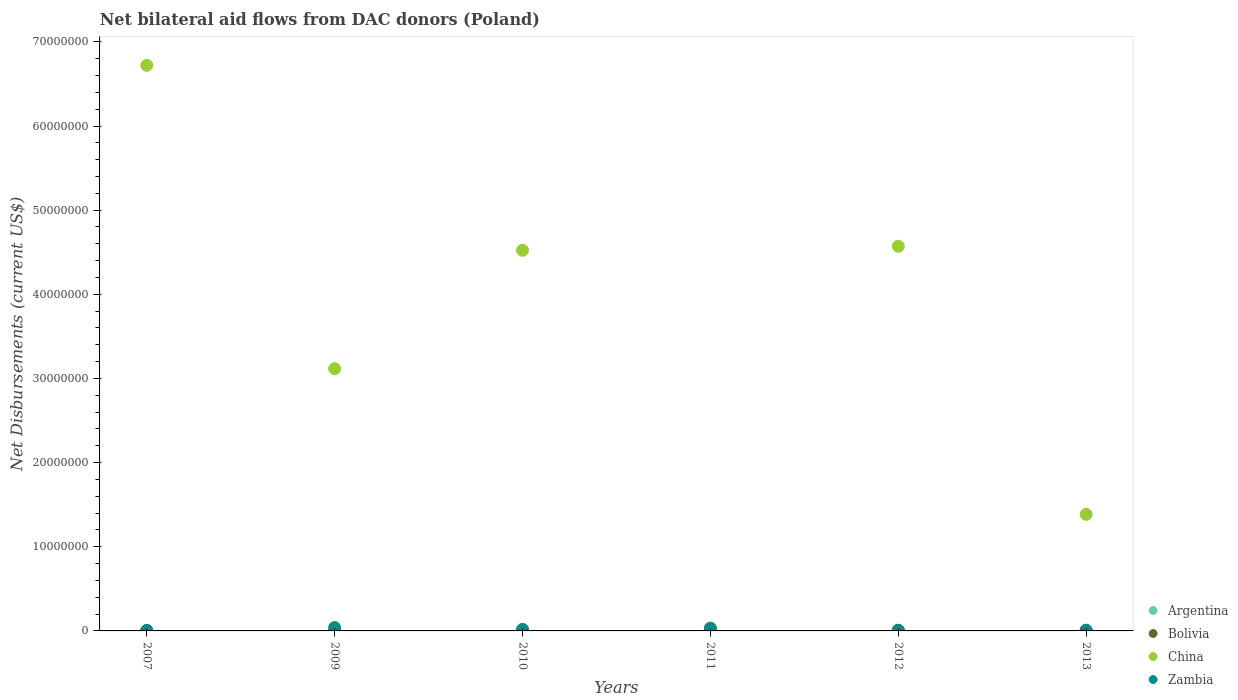How many different coloured dotlines are there?
Your answer should be very brief. 4. Is the number of dotlines equal to the number of legend labels?
Provide a succinct answer. No. What is the net bilateral aid flows in China in 2010?
Provide a short and direct response. 4.52e+07. Across all years, what is the maximum net bilateral aid flows in China?
Provide a succinct answer. 6.72e+07. What is the total net bilateral aid flows in Argentina in the graph?
Ensure brevity in your answer.  1.30e+05. What is the difference between the net bilateral aid flows in China in 2009 and that in 2012?
Make the answer very short. -1.46e+07. What is the difference between the net bilateral aid flows in Argentina in 2013 and the net bilateral aid flows in China in 2007?
Your response must be concise. -6.72e+07. What is the average net bilateral aid flows in China per year?
Offer a very short reply. 3.39e+07. In the year 2007, what is the difference between the net bilateral aid flows in China and net bilateral aid flows in Bolivia?
Offer a terse response. 6.72e+07. In how many years, is the net bilateral aid flows in Bolivia greater than 12000000 US$?
Make the answer very short. 0. What is the ratio of the net bilateral aid flows in Bolivia in 2007 to that in 2011?
Ensure brevity in your answer.  0.12. Is the difference between the net bilateral aid flows in China in 2009 and 2010 greater than the difference between the net bilateral aid flows in Bolivia in 2009 and 2010?
Provide a short and direct response. No. What is the difference between the highest and the second highest net bilateral aid flows in China?
Provide a short and direct response. 2.15e+07. What is the difference between the highest and the lowest net bilateral aid flows in China?
Provide a short and direct response. 6.72e+07. In how many years, is the net bilateral aid flows in Bolivia greater than the average net bilateral aid flows in Bolivia taken over all years?
Your answer should be very brief. 3. Is it the case that in every year, the sum of the net bilateral aid flows in Zambia and net bilateral aid flows in Bolivia  is greater than the sum of net bilateral aid flows in Argentina and net bilateral aid flows in China?
Offer a very short reply. No. How many dotlines are there?
Offer a terse response. 4. How many years are there in the graph?
Offer a very short reply. 6. Are the values on the major ticks of Y-axis written in scientific E-notation?
Offer a very short reply. No. Does the graph contain any zero values?
Give a very brief answer. Yes. Where does the legend appear in the graph?
Provide a succinct answer. Bottom right. How many legend labels are there?
Your response must be concise. 4. What is the title of the graph?
Make the answer very short. Net bilateral aid flows from DAC donors (Poland). Does "Madagascar" appear as one of the legend labels in the graph?
Make the answer very short. No. What is the label or title of the X-axis?
Your answer should be compact. Years. What is the label or title of the Y-axis?
Offer a very short reply. Net Disbursements (current US$). What is the Net Disbursements (current US$) of Bolivia in 2007?
Your answer should be very brief. 10000. What is the Net Disbursements (current US$) in China in 2007?
Your answer should be compact. 6.72e+07. What is the Net Disbursements (current US$) in China in 2009?
Give a very brief answer. 3.12e+07. What is the Net Disbursements (current US$) in Bolivia in 2010?
Your response must be concise. 3.00e+04. What is the Net Disbursements (current US$) of China in 2010?
Offer a terse response. 4.52e+07. What is the Net Disbursements (current US$) of Argentina in 2011?
Provide a short and direct response. 10000. What is the Net Disbursements (current US$) of Bolivia in 2011?
Give a very brief answer. 8.00e+04. What is the Net Disbursements (current US$) of China in 2011?
Give a very brief answer. 0. What is the Net Disbursements (current US$) of Zambia in 2011?
Provide a short and direct response. 3.30e+05. What is the Net Disbursements (current US$) in Bolivia in 2012?
Make the answer very short. 8.00e+04. What is the Net Disbursements (current US$) of China in 2012?
Ensure brevity in your answer.  4.57e+07. What is the Net Disbursements (current US$) in Zambia in 2012?
Your response must be concise. 6.00e+04. What is the Net Disbursements (current US$) in Argentina in 2013?
Offer a very short reply. 2.00e+04. What is the Net Disbursements (current US$) in China in 2013?
Give a very brief answer. 1.38e+07. Across all years, what is the maximum Net Disbursements (current US$) in Argentina?
Give a very brief answer. 5.00e+04. Across all years, what is the maximum Net Disbursements (current US$) of Bolivia?
Offer a very short reply. 9.00e+04. Across all years, what is the maximum Net Disbursements (current US$) of China?
Your answer should be compact. 6.72e+07. Across all years, what is the maximum Net Disbursements (current US$) of Zambia?
Provide a short and direct response. 4.00e+05. Across all years, what is the minimum Net Disbursements (current US$) in Argentina?
Provide a succinct answer. 10000. Across all years, what is the minimum Net Disbursements (current US$) in Bolivia?
Offer a terse response. 10000. Across all years, what is the minimum Net Disbursements (current US$) of China?
Offer a very short reply. 0. Across all years, what is the minimum Net Disbursements (current US$) of Zambia?
Keep it short and to the point. 6.00e+04. What is the total Net Disbursements (current US$) of Argentina in the graph?
Offer a terse response. 1.30e+05. What is the total Net Disbursements (current US$) of China in the graph?
Keep it short and to the point. 2.03e+08. What is the total Net Disbursements (current US$) in Zambia in the graph?
Keep it short and to the point. 1.10e+06. What is the difference between the Net Disbursements (current US$) in China in 2007 and that in 2009?
Make the answer very short. 3.60e+07. What is the difference between the Net Disbursements (current US$) in Zambia in 2007 and that in 2009?
Provide a short and direct response. -3.40e+05. What is the difference between the Net Disbursements (current US$) in Argentina in 2007 and that in 2010?
Your response must be concise. 4.00e+04. What is the difference between the Net Disbursements (current US$) of China in 2007 and that in 2010?
Your answer should be compact. 2.20e+07. What is the difference between the Net Disbursements (current US$) of Zambia in 2007 and that in 2010?
Your response must be concise. -1.30e+05. What is the difference between the Net Disbursements (current US$) in Bolivia in 2007 and that in 2011?
Your answer should be compact. -7.00e+04. What is the difference between the Net Disbursements (current US$) in Argentina in 2007 and that in 2012?
Your answer should be very brief. 3.00e+04. What is the difference between the Net Disbursements (current US$) of China in 2007 and that in 2012?
Give a very brief answer. 2.15e+07. What is the difference between the Net Disbursements (current US$) in Zambia in 2007 and that in 2012?
Provide a short and direct response. 0. What is the difference between the Net Disbursements (current US$) in Argentina in 2007 and that in 2013?
Ensure brevity in your answer.  3.00e+04. What is the difference between the Net Disbursements (current US$) of Bolivia in 2007 and that in 2013?
Offer a terse response. -8.00e+04. What is the difference between the Net Disbursements (current US$) in China in 2007 and that in 2013?
Your response must be concise. 5.34e+07. What is the difference between the Net Disbursements (current US$) in Argentina in 2009 and that in 2010?
Keep it short and to the point. 10000. What is the difference between the Net Disbursements (current US$) in China in 2009 and that in 2010?
Provide a short and direct response. -1.41e+07. What is the difference between the Net Disbursements (current US$) of Zambia in 2009 and that in 2010?
Offer a very short reply. 2.10e+05. What is the difference between the Net Disbursements (current US$) in Argentina in 2009 and that in 2011?
Your answer should be very brief. 10000. What is the difference between the Net Disbursements (current US$) of Bolivia in 2009 and that in 2012?
Offer a very short reply. -4.00e+04. What is the difference between the Net Disbursements (current US$) of China in 2009 and that in 2012?
Give a very brief answer. -1.46e+07. What is the difference between the Net Disbursements (current US$) in Zambia in 2009 and that in 2012?
Give a very brief answer. 3.40e+05. What is the difference between the Net Disbursements (current US$) in Argentina in 2009 and that in 2013?
Your answer should be very brief. 0. What is the difference between the Net Disbursements (current US$) of China in 2009 and that in 2013?
Your response must be concise. 1.73e+07. What is the difference between the Net Disbursements (current US$) of Argentina in 2010 and that in 2011?
Provide a short and direct response. 0. What is the difference between the Net Disbursements (current US$) in Zambia in 2010 and that in 2011?
Offer a terse response. -1.40e+05. What is the difference between the Net Disbursements (current US$) of Argentina in 2010 and that in 2012?
Offer a terse response. -10000. What is the difference between the Net Disbursements (current US$) in Bolivia in 2010 and that in 2012?
Ensure brevity in your answer.  -5.00e+04. What is the difference between the Net Disbursements (current US$) in China in 2010 and that in 2012?
Ensure brevity in your answer.  -4.80e+05. What is the difference between the Net Disbursements (current US$) in Zambia in 2010 and that in 2012?
Provide a short and direct response. 1.30e+05. What is the difference between the Net Disbursements (current US$) in Argentina in 2010 and that in 2013?
Make the answer very short. -10000. What is the difference between the Net Disbursements (current US$) in China in 2010 and that in 2013?
Make the answer very short. 3.14e+07. What is the difference between the Net Disbursements (current US$) in Zambia in 2010 and that in 2013?
Your response must be concise. 1.30e+05. What is the difference between the Net Disbursements (current US$) of Bolivia in 2011 and that in 2012?
Ensure brevity in your answer.  0. What is the difference between the Net Disbursements (current US$) in Zambia in 2011 and that in 2012?
Give a very brief answer. 2.70e+05. What is the difference between the Net Disbursements (current US$) in Argentina in 2011 and that in 2013?
Keep it short and to the point. -10000. What is the difference between the Net Disbursements (current US$) in Bolivia in 2011 and that in 2013?
Provide a succinct answer. -10000. What is the difference between the Net Disbursements (current US$) in Argentina in 2012 and that in 2013?
Your response must be concise. 0. What is the difference between the Net Disbursements (current US$) in China in 2012 and that in 2013?
Keep it short and to the point. 3.19e+07. What is the difference between the Net Disbursements (current US$) in Zambia in 2012 and that in 2013?
Give a very brief answer. 0. What is the difference between the Net Disbursements (current US$) of Argentina in 2007 and the Net Disbursements (current US$) of China in 2009?
Keep it short and to the point. -3.11e+07. What is the difference between the Net Disbursements (current US$) in Argentina in 2007 and the Net Disbursements (current US$) in Zambia in 2009?
Offer a terse response. -3.50e+05. What is the difference between the Net Disbursements (current US$) of Bolivia in 2007 and the Net Disbursements (current US$) of China in 2009?
Ensure brevity in your answer.  -3.12e+07. What is the difference between the Net Disbursements (current US$) in Bolivia in 2007 and the Net Disbursements (current US$) in Zambia in 2009?
Your answer should be compact. -3.90e+05. What is the difference between the Net Disbursements (current US$) in China in 2007 and the Net Disbursements (current US$) in Zambia in 2009?
Ensure brevity in your answer.  6.68e+07. What is the difference between the Net Disbursements (current US$) in Argentina in 2007 and the Net Disbursements (current US$) in China in 2010?
Provide a short and direct response. -4.52e+07. What is the difference between the Net Disbursements (current US$) in Bolivia in 2007 and the Net Disbursements (current US$) in China in 2010?
Provide a succinct answer. -4.52e+07. What is the difference between the Net Disbursements (current US$) in Bolivia in 2007 and the Net Disbursements (current US$) in Zambia in 2010?
Give a very brief answer. -1.80e+05. What is the difference between the Net Disbursements (current US$) in China in 2007 and the Net Disbursements (current US$) in Zambia in 2010?
Make the answer very short. 6.70e+07. What is the difference between the Net Disbursements (current US$) of Argentina in 2007 and the Net Disbursements (current US$) of Bolivia in 2011?
Your response must be concise. -3.00e+04. What is the difference between the Net Disbursements (current US$) in Argentina in 2007 and the Net Disbursements (current US$) in Zambia in 2011?
Give a very brief answer. -2.80e+05. What is the difference between the Net Disbursements (current US$) in Bolivia in 2007 and the Net Disbursements (current US$) in Zambia in 2011?
Ensure brevity in your answer.  -3.20e+05. What is the difference between the Net Disbursements (current US$) in China in 2007 and the Net Disbursements (current US$) in Zambia in 2011?
Your response must be concise. 6.69e+07. What is the difference between the Net Disbursements (current US$) in Argentina in 2007 and the Net Disbursements (current US$) in China in 2012?
Make the answer very short. -4.57e+07. What is the difference between the Net Disbursements (current US$) of Bolivia in 2007 and the Net Disbursements (current US$) of China in 2012?
Offer a terse response. -4.57e+07. What is the difference between the Net Disbursements (current US$) in China in 2007 and the Net Disbursements (current US$) in Zambia in 2012?
Provide a short and direct response. 6.72e+07. What is the difference between the Net Disbursements (current US$) in Argentina in 2007 and the Net Disbursements (current US$) in China in 2013?
Your answer should be compact. -1.38e+07. What is the difference between the Net Disbursements (current US$) of Argentina in 2007 and the Net Disbursements (current US$) of Zambia in 2013?
Ensure brevity in your answer.  -10000. What is the difference between the Net Disbursements (current US$) of Bolivia in 2007 and the Net Disbursements (current US$) of China in 2013?
Your answer should be compact. -1.38e+07. What is the difference between the Net Disbursements (current US$) in China in 2007 and the Net Disbursements (current US$) in Zambia in 2013?
Ensure brevity in your answer.  6.72e+07. What is the difference between the Net Disbursements (current US$) of Argentina in 2009 and the Net Disbursements (current US$) of Bolivia in 2010?
Make the answer very short. -10000. What is the difference between the Net Disbursements (current US$) of Argentina in 2009 and the Net Disbursements (current US$) of China in 2010?
Make the answer very short. -4.52e+07. What is the difference between the Net Disbursements (current US$) of Bolivia in 2009 and the Net Disbursements (current US$) of China in 2010?
Your response must be concise. -4.52e+07. What is the difference between the Net Disbursements (current US$) of Bolivia in 2009 and the Net Disbursements (current US$) of Zambia in 2010?
Offer a very short reply. -1.50e+05. What is the difference between the Net Disbursements (current US$) of China in 2009 and the Net Disbursements (current US$) of Zambia in 2010?
Provide a succinct answer. 3.10e+07. What is the difference between the Net Disbursements (current US$) of Argentina in 2009 and the Net Disbursements (current US$) of Zambia in 2011?
Make the answer very short. -3.10e+05. What is the difference between the Net Disbursements (current US$) in China in 2009 and the Net Disbursements (current US$) in Zambia in 2011?
Your answer should be compact. 3.08e+07. What is the difference between the Net Disbursements (current US$) in Argentina in 2009 and the Net Disbursements (current US$) in Bolivia in 2012?
Provide a succinct answer. -6.00e+04. What is the difference between the Net Disbursements (current US$) of Argentina in 2009 and the Net Disbursements (current US$) of China in 2012?
Ensure brevity in your answer.  -4.57e+07. What is the difference between the Net Disbursements (current US$) of Argentina in 2009 and the Net Disbursements (current US$) of Zambia in 2012?
Your answer should be compact. -4.00e+04. What is the difference between the Net Disbursements (current US$) of Bolivia in 2009 and the Net Disbursements (current US$) of China in 2012?
Provide a succinct answer. -4.57e+07. What is the difference between the Net Disbursements (current US$) of China in 2009 and the Net Disbursements (current US$) of Zambia in 2012?
Provide a succinct answer. 3.11e+07. What is the difference between the Net Disbursements (current US$) of Argentina in 2009 and the Net Disbursements (current US$) of Bolivia in 2013?
Keep it short and to the point. -7.00e+04. What is the difference between the Net Disbursements (current US$) in Argentina in 2009 and the Net Disbursements (current US$) in China in 2013?
Your answer should be very brief. -1.38e+07. What is the difference between the Net Disbursements (current US$) of Bolivia in 2009 and the Net Disbursements (current US$) of China in 2013?
Your response must be concise. -1.38e+07. What is the difference between the Net Disbursements (current US$) in Bolivia in 2009 and the Net Disbursements (current US$) in Zambia in 2013?
Provide a succinct answer. -2.00e+04. What is the difference between the Net Disbursements (current US$) in China in 2009 and the Net Disbursements (current US$) in Zambia in 2013?
Ensure brevity in your answer.  3.11e+07. What is the difference between the Net Disbursements (current US$) in Argentina in 2010 and the Net Disbursements (current US$) in Zambia in 2011?
Give a very brief answer. -3.20e+05. What is the difference between the Net Disbursements (current US$) of Bolivia in 2010 and the Net Disbursements (current US$) of Zambia in 2011?
Keep it short and to the point. -3.00e+05. What is the difference between the Net Disbursements (current US$) of China in 2010 and the Net Disbursements (current US$) of Zambia in 2011?
Offer a very short reply. 4.49e+07. What is the difference between the Net Disbursements (current US$) of Argentina in 2010 and the Net Disbursements (current US$) of China in 2012?
Ensure brevity in your answer.  -4.57e+07. What is the difference between the Net Disbursements (current US$) of Bolivia in 2010 and the Net Disbursements (current US$) of China in 2012?
Offer a terse response. -4.57e+07. What is the difference between the Net Disbursements (current US$) of Bolivia in 2010 and the Net Disbursements (current US$) of Zambia in 2012?
Provide a succinct answer. -3.00e+04. What is the difference between the Net Disbursements (current US$) of China in 2010 and the Net Disbursements (current US$) of Zambia in 2012?
Your answer should be very brief. 4.52e+07. What is the difference between the Net Disbursements (current US$) of Argentina in 2010 and the Net Disbursements (current US$) of China in 2013?
Offer a terse response. -1.38e+07. What is the difference between the Net Disbursements (current US$) of Bolivia in 2010 and the Net Disbursements (current US$) of China in 2013?
Your answer should be compact. -1.38e+07. What is the difference between the Net Disbursements (current US$) in China in 2010 and the Net Disbursements (current US$) in Zambia in 2013?
Your response must be concise. 4.52e+07. What is the difference between the Net Disbursements (current US$) in Argentina in 2011 and the Net Disbursements (current US$) in China in 2012?
Offer a terse response. -4.57e+07. What is the difference between the Net Disbursements (current US$) in Argentina in 2011 and the Net Disbursements (current US$) in Zambia in 2012?
Offer a very short reply. -5.00e+04. What is the difference between the Net Disbursements (current US$) in Bolivia in 2011 and the Net Disbursements (current US$) in China in 2012?
Your answer should be compact. -4.56e+07. What is the difference between the Net Disbursements (current US$) of Bolivia in 2011 and the Net Disbursements (current US$) of Zambia in 2012?
Provide a short and direct response. 2.00e+04. What is the difference between the Net Disbursements (current US$) in Argentina in 2011 and the Net Disbursements (current US$) in China in 2013?
Ensure brevity in your answer.  -1.38e+07. What is the difference between the Net Disbursements (current US$) of Argentina in 2011 and the Net Disbursements (current US$) of Zambia in 2013?
Keep it short and to the point. -5.00e+04. What is the difference between the Net Disbursements (current US$) of Bolivia in 2011 and the Net Disbursements (current US$) of China in 2013?
Keep it short and to the point. -1.38e+07. What is the difference between the Net Disbursements (current US$) in Bolivia in 2011 and the Net Disbursements (current US$) in Zambia in 2013?
Make the answer very short. 2.00e+04. What is the difference between the Net Disbursements (current US$) in Argentina in 2012 and the Net Disbursements (current US$) in Bolivia in 2013?
Offer a terse response. -7.00e+04. What is the difference between the Net Disbursements (current US$) in Argentina in 2012 and the Net Disbursements (current US$) in China in 2013?
Offer a terse response. -1.38e+07. What is the difference between the Net Disbursements (current US$) in Bolivia in 2012 and the Net Disbursements (current US$) in China in 2013?
Your response must be concise. -1.38e+07. What is the difference between the Net Disbursements (current US$) of Bolivia in 2012 and the Net Disbursements (current US$) of Zambia in 2013?
Your answer should be compact. 2.00e+04. What is the difference between the Net Disbursements (current US$) of China in 2012 and the Net Disbursements (current US$) of Zambia in 2013?
Offer a very short reply. 4.56e+07. What is the average Net Disbursements (current US$) in Argentina per year?
Keep it short and to the point. 2.17e+04. What is the average Net Disbursements (current US$) in Bolivia per year?
Keep it short and to the point. 5.50e+04. What is the average Net Disbursements (current US$) in China per year?
Offer a very short reply. 3.39e+07. What is the average Net Disbursements (current US$) of Zambia per year?
Ensure brevity in your answer.  1.83e+05. In the year 2007, what is the difference between the Net Disbursements (current US$) in Argentina and Net Disbursements (current US$) in China?
Keep it short and to the point. -6.72e+07. In the year 2007, what is the difference between the Net Disbursements (current US$) in Argentina and Net Disbursements (current US$) in Zambia?
Provide a succinct answer. -10000. In the year 2007, what is the difference between the Net Disbursements (current US$) in Bolivia and Net Disbursements (current US$) in China?
Give a very brief answer. -6.72e+07. In the year 2007, what is the difference between the Net Disbursements (current US$) of China and Net Disbursements (current US$) of Zambia?
Your answer should be very brief. 6.72e+07. In the year 2009, what is the difference between the Net Disbursements (current US$) of Argentina and Net Disbursements (current US$) of China?
Keep it short and to the point. -3.11e+07. In the year 2009, what is the difference between the Net Disbursements (current US$) of Argentina and Net Disbursements (current US$) of Zambia?
Provide a succinct answer. -3.80e+05. In the year 2009, what is the difference between the Net Disbursements (current US$) in Bolivia and Net Disbursements (current US$) in China?
Offer a very short reply. -3.11e+07. In the year 2009, what is the difference between the Net Disbursements (current US$) in Bolivia and Net Disbursements (current US$) in Zambia?
Your answer should be compact. -3.60e+05. In the year 2009, what is the difference between the Net Disbursements (current US$) in China and Net Disbursements (current US$) in Zambia?
Keep it short and to the point. 3.08e+07. In the year 2010, what is the difference between the Net Disbursements (current US$) in Argentina and Net Disbursements (current US$) in China?
Provide a short and direct response. -4.52e+07. In the year 2010, what is the difference between the Net Disbursements (current US$) of Bolivia and Net Disbursements (current US$) of China?
Your response must be concise. -4.52e+07. In the year 2010, what is the difference between the Net Disbursements (current US$) of China and Net Disbursements (current US$) of Zambia?
Provide a succinct answer. 4.50e+07. In the year 2011, what is the difference between the Net Disbursements (current US$) of Argentina and Net Disbursements (current US$) of Bolivia?
Provide a short and direct response. -7.00e+04. In the year 2011, what is the difference between the Net Disbursements (current US$) in Argentina and Net Disbursements (current US$) in Zambia?
Keep it short and to the point. -3.20e+05. In the year 2012, what is the difference between the Net Disbursements (current US$) of Argentina and Net Disbursements (current US$) of China?
Offer a very short reply. -4.57e+07. In the year 2012, what is the difference between the Net Disbursements (current US$) in Argentina and Net Disbursements (current US$) in Zambia?
Offer a terse response. -4.00e+04. In the year 2012, what is the difference between the Net Disbursements (current US$) in Bolivia and Net Disbursements (current US$) in China?
Offer a terse response. -4.56e+07. In the year 2012, what is the difference between the Net Disbursements (current US$) of Bolivia and Net Disbursements (current US$) of Zambia?
Make the answer very short. 2.00e+04. In the year 2012, what is the difference between the Net Disbursements (current US$) in China and Net Disbursements (current US$) in Zambia?
Your answer should be compact. 4.56e+07. In the year 2013, what is the difference between the Net Disbursements (current US$) of Argentina and Net Disbursements (current US$) of Bolivia?
Your answer should be very brief. -7.00e+04. In the year 2013, what is the difference between the Net Disbursements (current US$) of Argentina and Net Disbursements (current US$) of China?
Keep it short and to the point. -1.38e+07. In the year 2013, what is the difference between the Net Disbursements (current US$) of Bolivia and Net Disbursements (current US$) of China?
Provide a short and direct response. -1.38e+07. In the year 2013, what is the difference between the Net Disbursements (current US$) of Bolivia and Net Disbursements (current US$) of Zambia?
Provide a succinct answer. 3.00e+04. In the year 2013, what is the difference between the Net Disbursements (current US$) in China and Net Disbursements (current US$) in Zambia?
Provide a succinct answer. 1.38e+07. What is the ratio of the Net Disbursements (current US$) in Argentina in 2007 to that in 2009?
Make the answer very short. 2.5. What is the ratio of the Net Disbursements (current US$) of Bolivia in 2007 to that in 2009?
Ensure brevity in your answer.  0.25. What is the ratio of the Net Disbursements (current US$) of China in 2007 to that in 2009?
Your answer should be very brief. 2.16. What is the ratio of the Net Disbursements (current US$) in Argentina in 2007 to that in 2010?
Your response must be concise. 5. What is the ratio of the Net Disbursements (current US$) of China in 2007 to that in 2010?
Keep it short and to the point. 1.49. What is the ratio of the Net Disbursements (current US$) of Zambia in 2007 to that in 2010?
Your response must be concise. 0.32. What is the ratio of the Net Disbursements (current US$) of Argentina in 2007 to that in 2011?
Make the answer very short. 5. What is the ratio of the Net Disbursements (current US$) of Zambia in 2007 to that in 2011?
Offer a terse response. 0.18. What is the ratio of the Net Disbursements (current US$) in China in 2007 to that in 2012?
Ensure brevity in your answer.  1.47. What is the ratio of the Net Disbursements (current US$) in Bolivia in 2007 to that in 2013?
Your response must be concise. 0.11. What is the ratio of the Net Disbursements (current US$) of China in 2007 to that in 2013?
Your answer should be compact. 4.85. What is the ratio of the Net Disbursements (current US$) in Argentina in 2009 to that in 2010?
Provide a succinct answer. 2. What is the ratio of the Net Disbursements (current US$) of China in 2009 to that in 2010?
Keep it short and to the point. 0.69. What is the ratio of the Net Disbursements (current US$) in Zambia in 2009 to that in 2010?
Provide a short and direct response. 2.11. What is the ratio of the Net Disbursements (current US$) of Argentina in 2009 to that in 2011?
Your response must be concise. 2. What is the ratio of the Net Disbursements (current US$) in Bolivia in 2009 to that in 2011?
Your response must be concise. 0.5. What is the ratio of the Net Disbursements (current US$) in Zambia in 2009 to that in 2011?
Offer a terse response. 1.21. What is the ratio of the Net Disbursements (current US$) of Argentina in 2009 to that in 2012?
Your answer should be compact. 1. What is the ratio of the Net Disbursements (current US$) of China in 2009 to that in 2012?
Offer a terse response. 0.68. What is the ratio of the Net Disbursements (current US$) of Zambia in 2009 to that in 2012?
Make the answer very short. 6.67. What is the ratio of the Net Disbursements (current US$) in Argentina in 2009 to that in 2013?
Offer a terse response. 1. What is the ratio of the Net Disbursements (current US$) of Bolivia in 2009 to that in 2013?
Make the answer very short. 0.44. What is the ratio of the Net Disbursements (current US$) of China in 2009 to that in 2013?
Offer a terse response. 2.25. What is the ratio of the Net Disbursements (current US$) in Zambia in 2009 to that in 2013?
Offer a very short reply. 6.67. What is the ratio of the Net Disbursements (current US$) in Zambia in 2010 to that in 2011?
Your answer should be very brief. 0.58. What is the ratio of the Net Disbursements (current US$) in Zambia in 2010 to that in 2012?
Keep it short and to the point. 3.17. What is the ratio of the Net Disbursements (current US$) in Argentina in 2010 to that in 2013?
Your answer should be very brief. 0.5. What is the ratio of the Net Disbursements (current US$) of China in 2010 to that in 2013?
Keep it short and to the point. 3.27. What is the ratio of the Net Disbursements (current US$) of Zambia in 2010 to that in 2013?
Your answer should be compact. 3.17. What is the ratio of the Net Disbursements (current US$) of Zambia in 2011 to that in 2012?
Keep it short and to the point. 5.5. What is the ratio of the Net Disbursements (current US$) in Bolivia in 2011 to that in 2013?
Offer a very short reply. 0.89. What is the ratio of the Net Disbursements (current US$) of Argentina in 2012 to that in 2013?
Provide a succinct answer. 1. What is the ratio of the Net Disbursements (current US$) of Bolivia in 2012 to that in 2013?
Provide a succinct answer. 0.89. What is the ratio of the Net Disbursements (current US$) of China in 2012 to that in 2013?
Provide a succinct answer. 3.3. What is the difference between the highest and the second highest Net Disbursements (current US$) of Argentina?
Keep it short and to the point. 3.00e+04. What is the difference between the highest and the second highest Net Disbursements (current US$) in Bolivia?
Offer a very short reply. 10000. What is the difference between the highest and the second highest Net Disbursements (current US$) in China?
Your answer should be compact. 2.15e+07. What is the difference between the highest and the lowest Net Disbursements (current US$) of Bolivia?
Ensure brevity in your answer.  8.00e+04. What is the difference between the highest and the lowest Net Disbursements (current US$) in China?
Make the answer very short. 6.72e+07. What is the difference between the highest and the lowest Net Disbursements (current US$) of Zambia?
Your answer should be compact. 3.40e+05. 